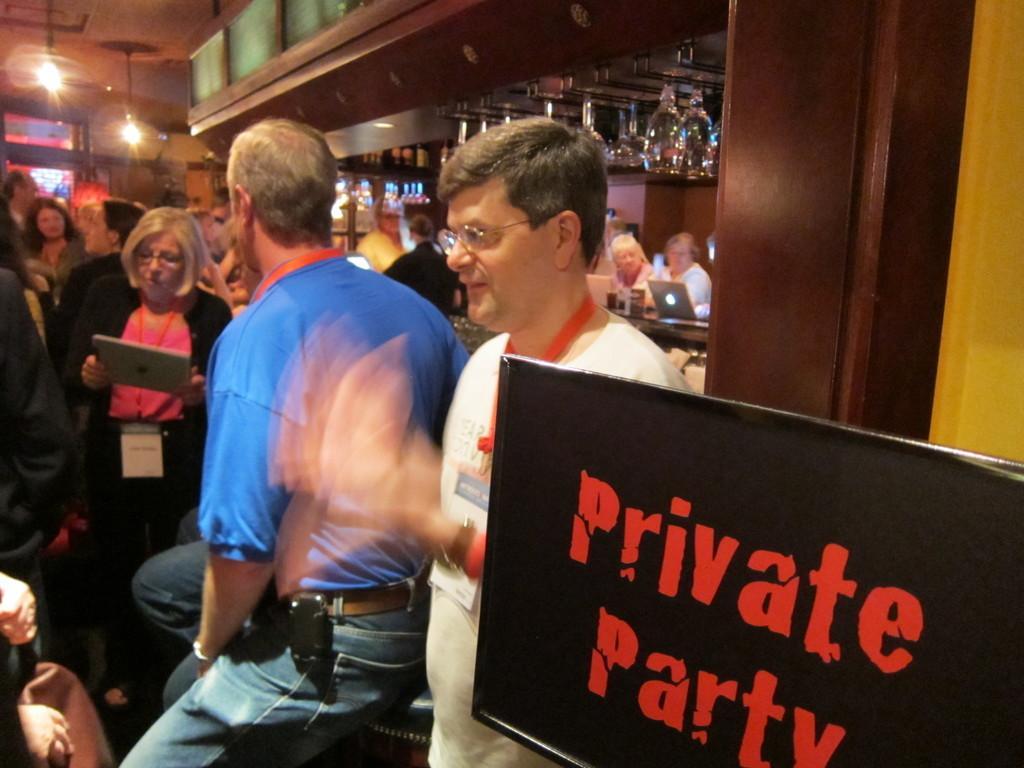Describe this image in one or two sentences. In this picture I can see crowd of people visible on left side and I can see a black color board at the bottom , on the board I can see text and I can see there are laptops and glass bottles and persons visible in the middle I can see brown color beam on the right side , in the top left I can see a light. 